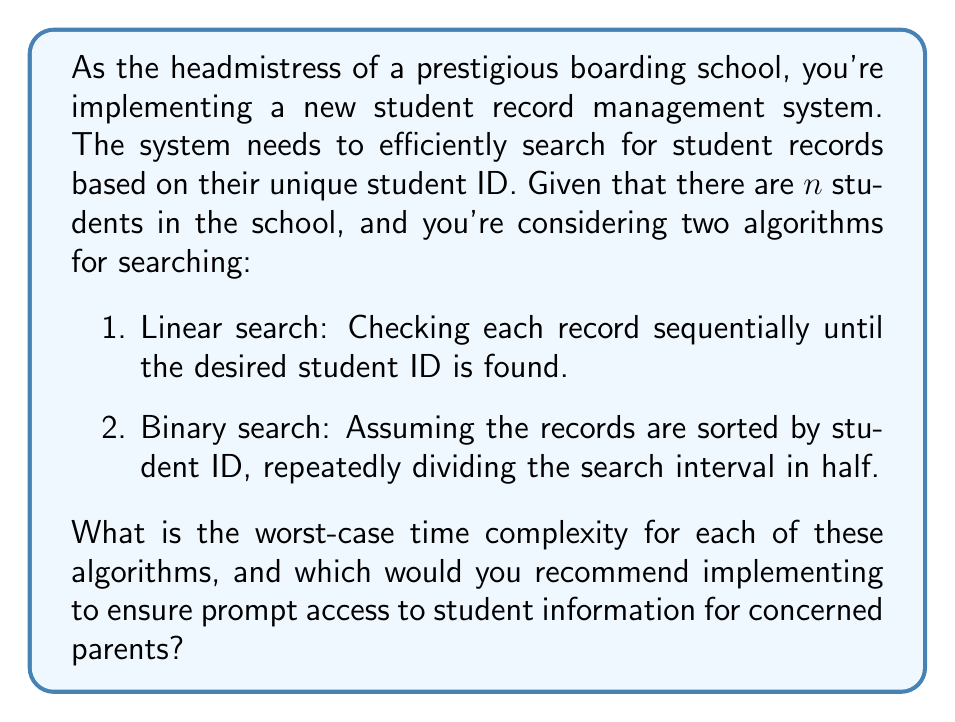What is the answer to this math problem? To analyze the time complexity of these algorithms, we need to consider the number of operations performed in the worst-case scenario for each:

1. Linear Search:
   In the worst case, the desired student ID is at the end of the list or not present at all. The algorithm would need to check every single record.
   
   Number of operations: $n$
   Time complexity: $O(n)$

2. Binary Search:
   In each step, the search space is divided in half. The worst case occurs when the target element is at one of the ends of the list or not present.
   
   Number of operations: $\log_2(n)$
   Time complexity: $O(\log n)$

To understand why binary search is $O(\log n)$, consider that in each step, we eliminate half of the remaining elements:

$$n \rightarrow \frac{n}{2} \rightarrow \frac{n}{4} \rightarrow \frac{n}{8} \rightarrow ... \rightarrow 1$$

The number of steps to reach 1 is $\log_2(n)$.

Comparing the two:
- For small $n$, the difference may not be significant.
- As $n$ grows larger, binary search becomes increasingly more efficient.

For example:
- If $n = 1000$, linear search might take up to 1000 operations, while binary search would take at most 10 operations ($\log_2(1000) \approx 9.97$).
- If $n = 1,000,000$, linear search could take up to 1,000,000 operations, while binary search would take at most 20 operations ($\log_2(1,000,000) \approx 19.93$).

As the headmistress, considering the need for quick access to student information, especially when addressing parental concerns, the binary search algorithm would be the recommended choice. It provides significantly faster access times, especially as the number of student records grows.

However, it's important to note that to use binary search, the records must be kept sorted by student ID, which may require additional maintenance when adding or removing student records.
Answer: Linear search: $O(n)$
Binary search: $O(\log n)$
Recommendation: Implement binary search for faster access to student records, especially as the number of students grows. 